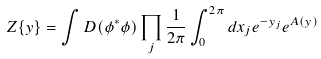<formula> <loc_0><loc_0><loc_500><loc_500>Z \{ y \} = \int D ( \phi ^ { * } \phi ) \prod _ { j } \frac { 1 } { 2 \pi } \int _ { 0 } ^ { 2 \pi } d x _ { j } e ^ { - y _ { j } } e ^ { A ( y ) }</formula> 